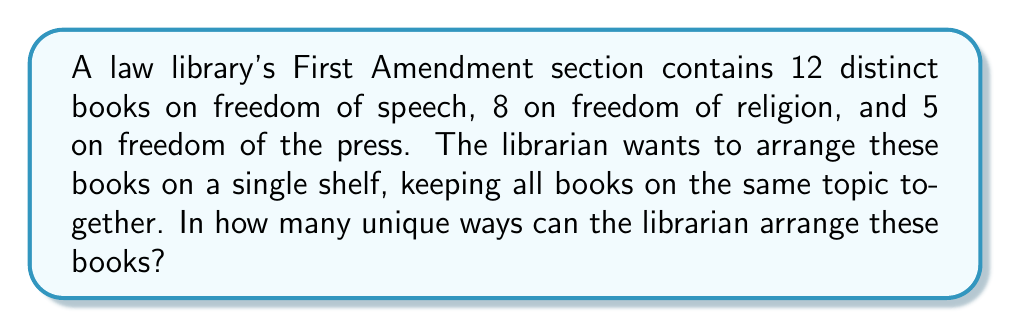Can you solve this math problem? Let's approach this step-by-step:

1) First, we need to consider the arrangement of the three topics (speech, religion, and press). This can be done in $3!$ ways.

2) Within each topic, the books can be arranged in different ways:
   - Freedom of speech books: $12!$ ways
   - Freedom of religion books: $8!$ ways
   - Freedom of the press books: $5!$ ways

3) By the multiplication principle, the total number of ways to arrange the books is:

   $$ 3! \times 12! \times 8! \times 5! $$

4) Let's calculate this:
   $$ 3! \times 12! \times 8! \times 5! $$
   $$ = 6 \times 479,001,600 \times 40,320 \times 120 $$
   $$ = 13,841,287,201,280,000 $$

Therefore, there are 13,841,287,201,280,000 unique ways to arrange the books.
Answer: $13,841,287,201,280,000$ 